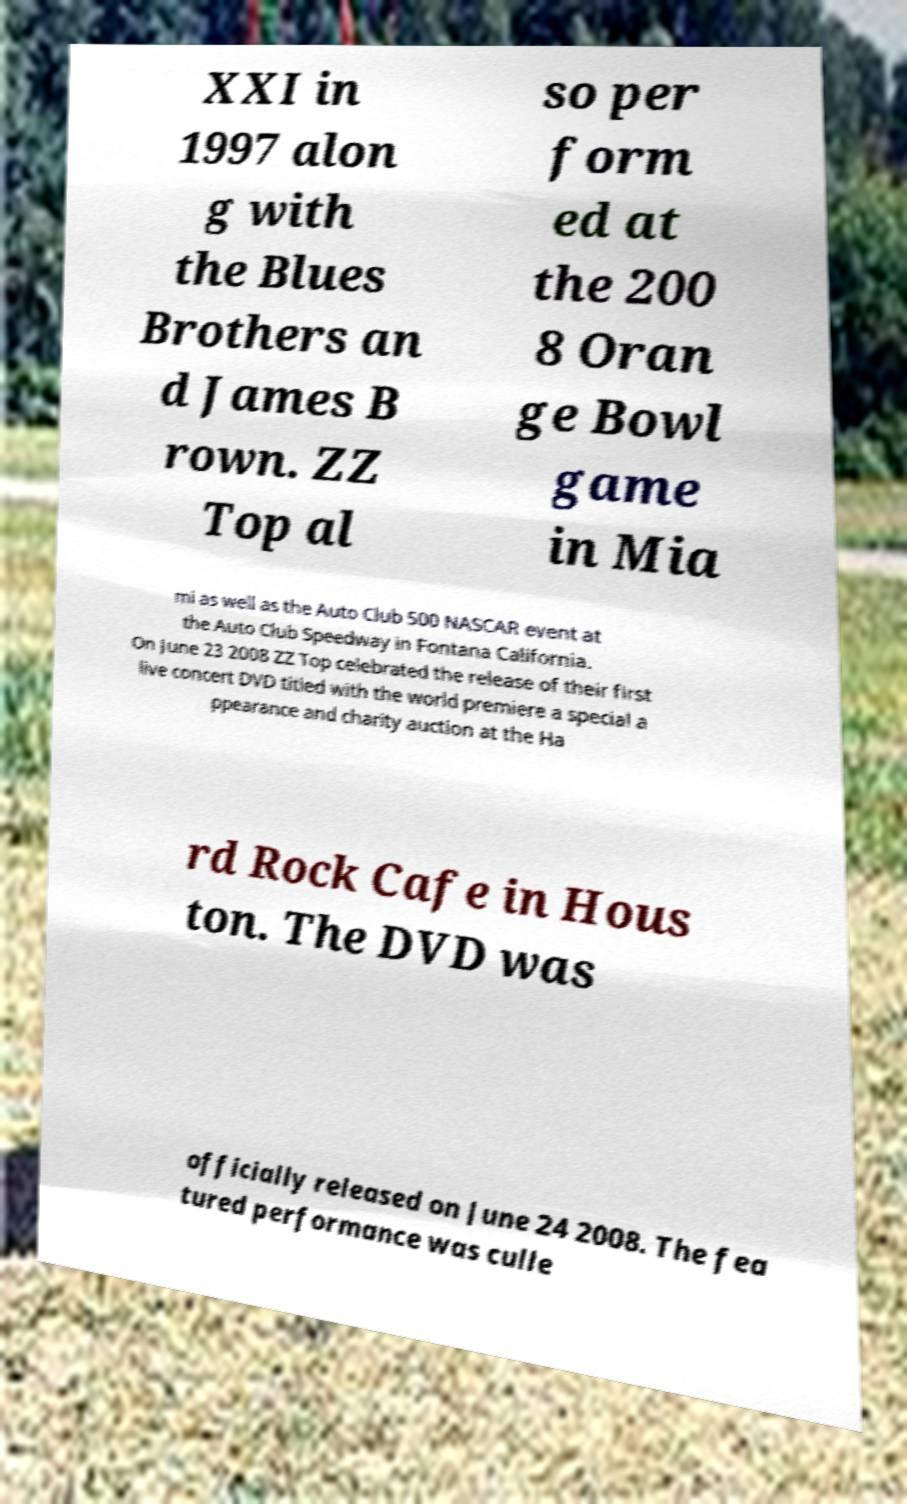Can you read and provide the text displayed in the image?This photo seems to have some interesting text. Can you extract and type it out for me? XXI in 1997 alon g with the Blues Brothers an d James B rown. ZZ Top al so per form ed at the 200 8 Oran ge Bowl game in Mia mi as well as the Auto Club 500 NASCAR event at the Auto Club Speedway in Fontana California. On June 23 2008 ZZ Top celebrated the release of their first live concert DVD titled with the world premiere a special a ppearance and charity auction at the Ha rd Rock Cafe in Hous ton. The DVD was officially released on June 24 2008. The fea tured performance was culle 